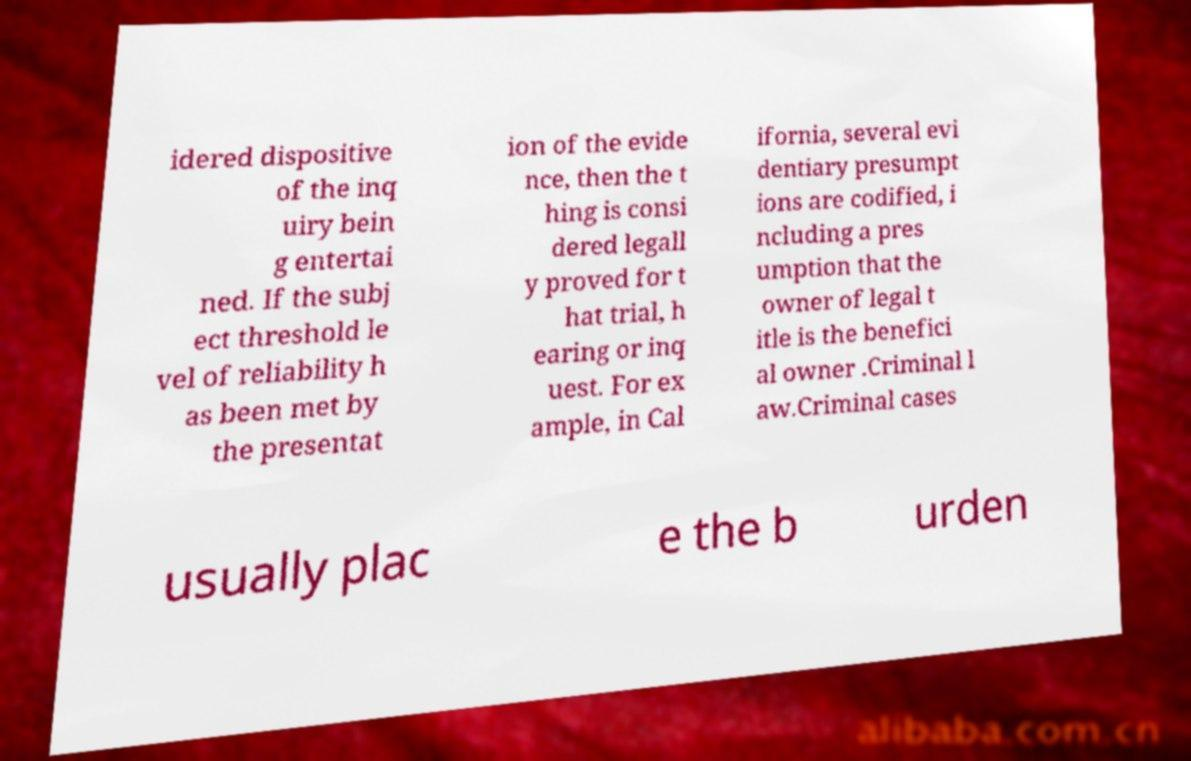There's text embedded in this image that I need extracted. Can you transcribe it verbatim? idered dispositive of the inq uiry bein g entertai ned. If the subj ect threshold le vel of reliability h as been met by the presentat ion of the evide nce, then the t hing is consi dered legall y proved for t hat trial, h earing or inq uest. For ex ample, in Cal ifornia, several evi dentiary presumpt ions are codified, i ncluding a pres umption that the owner of legal t itle is the benefici al owner .Criminal l aw.Criminal cases usually plac e the b urden 